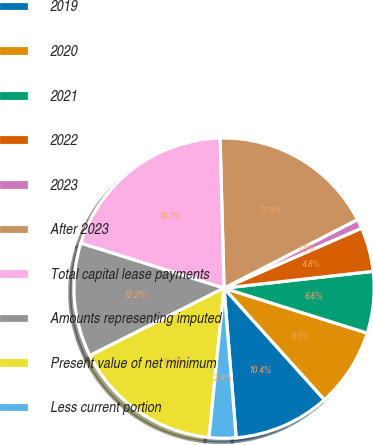<chart> <loc_0><loc_0><loc_500><loc_500><pie_chart><fcel>2019<fcel>2020<fcel>2021<fcel>2022<fcel>2023<fcel>After 2023<fcel>Total capital lease payments<fcel>Amounts representing imputed<fcel>Present value of net minimum<fcel>Less current portion<nl><fcel>10.37%<fcel>8.5%<fcel>6.63%<fcel>4.75%<fcel>1.01%<fcel>17.87%<fcel>19.74%<fcel>12.25%<fcel>16.0%<fcel>2.88%<nl></chart> 